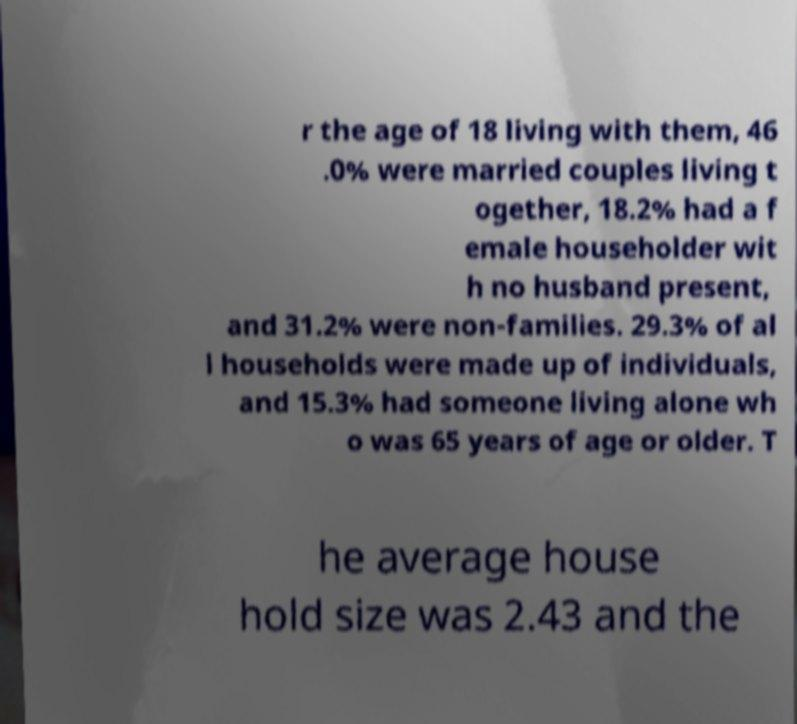There's text embedded in this image that I need extracted. Can you transcribe it verbatim? r the age of 18 living with them, 46 .0% were married couples living t ogether, 18.2% had a f emale householder wit h no husband present, and 31.2% were non-families. 29.3% of al l households were made up of individuals, and 15.3% had someone living alone wh o was 65 years of age or older. T he average house hold size was 2.43 and the 